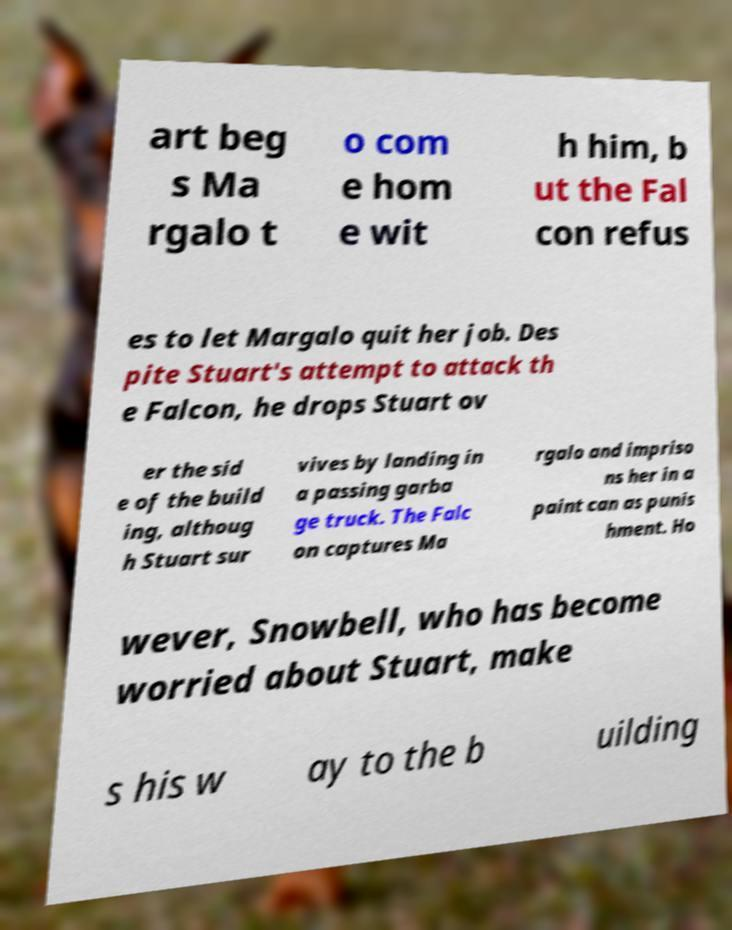Could you extract and type out the text from this image? art beg s Ma rgalo t o com e hom e wit h him, b ut the Fal con refus es to let Margalo quit her job. Des pite Stuart's attempt to attack th e Falcon, he drops Stuart ov er the sid e of the build ing, althoug h Stuart sur vives by landing in a passing garba ge truck. The Falc on captures Ma rgalo and impriso ns her in a paint can as punis hment. Ho wever, Snowbell, who has become worried about Stuart, make s his w ay to the b uilding 